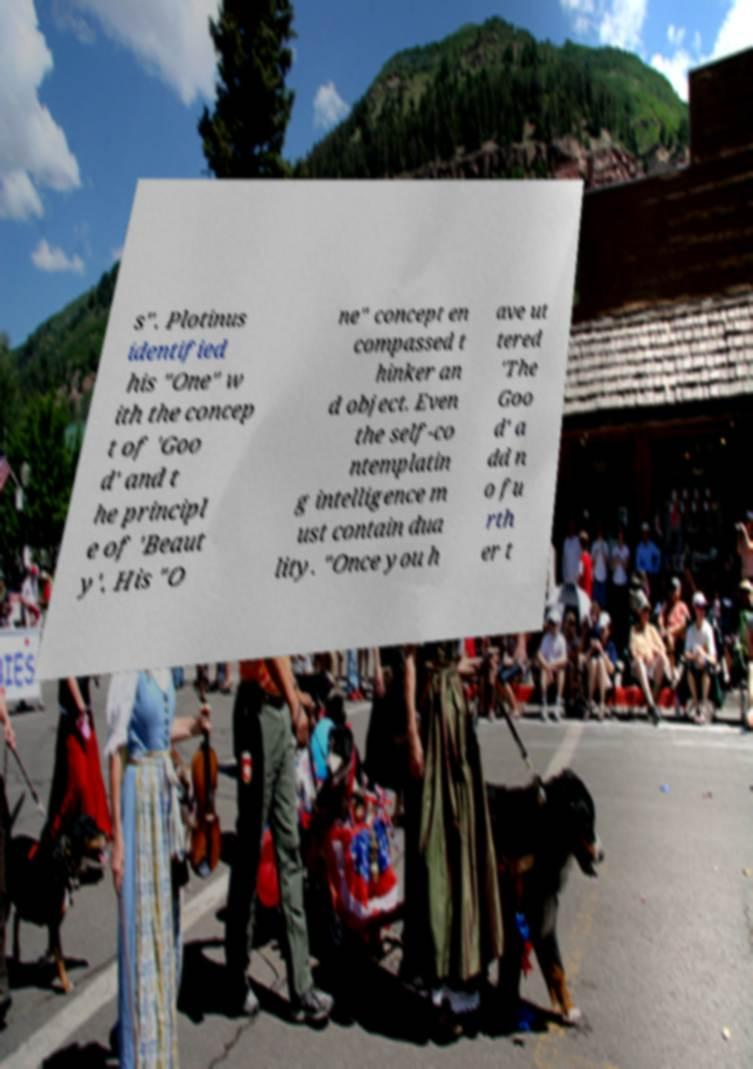What messages or text are displayed in this image? I need them in a readable, typed format. s". Plotinus identified his "One" w ith the concep t of 'Goo d' and t he principl e of 'Beaut y'. His "O ne" concept en compassed t hinker an d object. Even the self-co ntemplatin g intelligence m ust contain dua lity. "Once you h ave ut tered 'The Goo d' a dd n o fu rth er t 